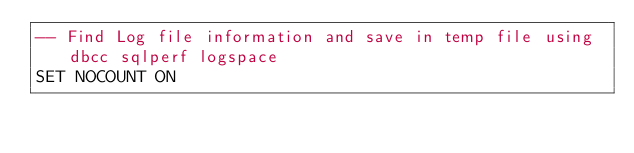Convert code to text. <code><loc_0><loc_0><loc_500><loc_500><_SQL_>-- Find Log file information and save in temp file using dbcc sqlperf logspace
SET NOCOUNT ON
</code> 